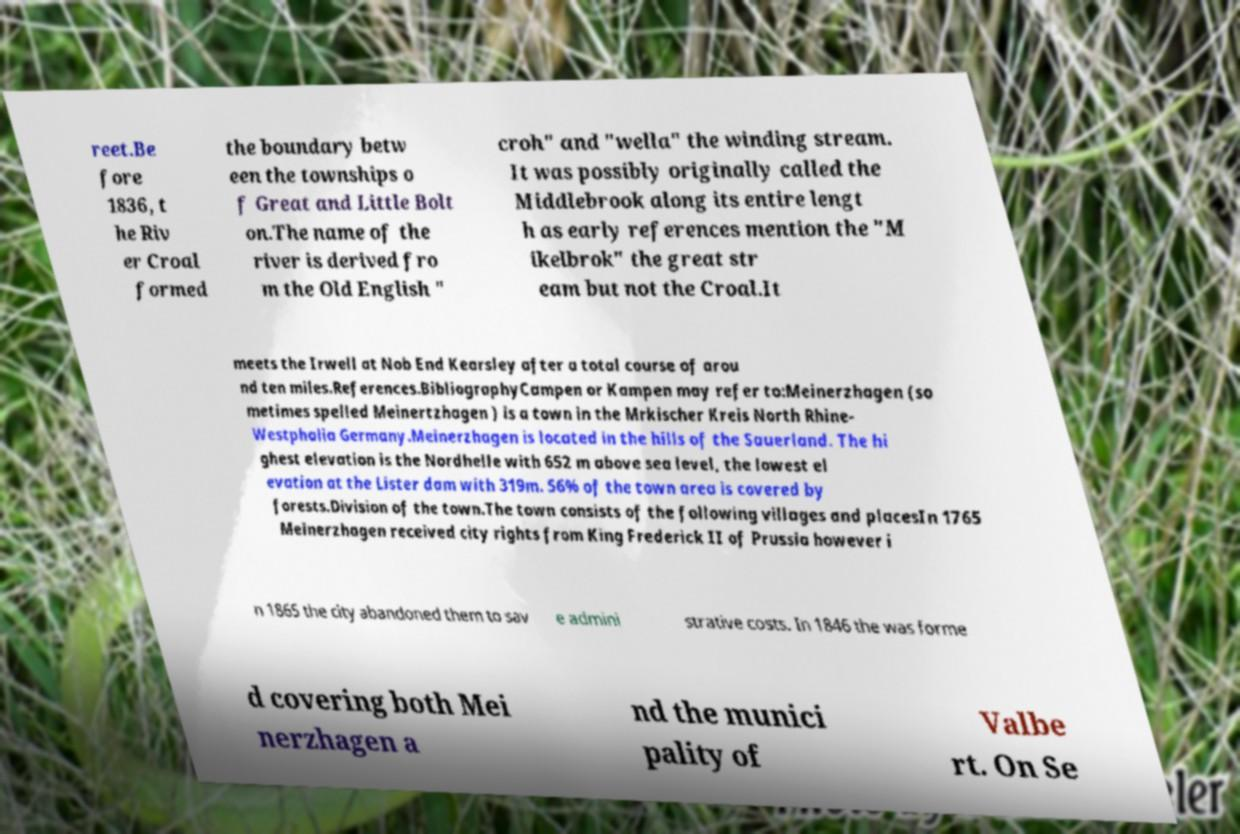For documentation purposes, I need the text within this image transcribed. Could you provide that? reet.Be fore 1836, t he Riv er Croal formed the boundary betw een the townships o f Great and Little Bolt on.The name of the river is derived fro m the Old English " croh" and "wella" the winding stream. It was possibly originally called the Middlebrook along its entire lengt h as early references mention the "M ikelbrok" the great str eam but not the Croal.It meets the Irwell at Nob End Kearsley after a total course of arou nd ten miles.References.BibliographyCampen or Kampen may refer to:Meinerzhagen (so metimes spelled Meinertzhagen ) is a town in the Mrkischer Kreis North Rhine- Westphalia Germany.Meinerzhagen is located in the hills of the Sauerland. The hi ghest elevation is the Nordhelle with 652 m above sea level, the lowest el evation at the Lister dam with 319m. 56% of the town area is covered by forests.Division of the town.The town consists of the following villages and placesIn 1765 Meinerzhagen received city rights from King Frederick II of Prussia however i n 1865 the city abandoned them to sav e admini strative costs. In 1846 the was forme d covering both Mei nerzhagen a nd the munici pality of Valbe rt. On Se 